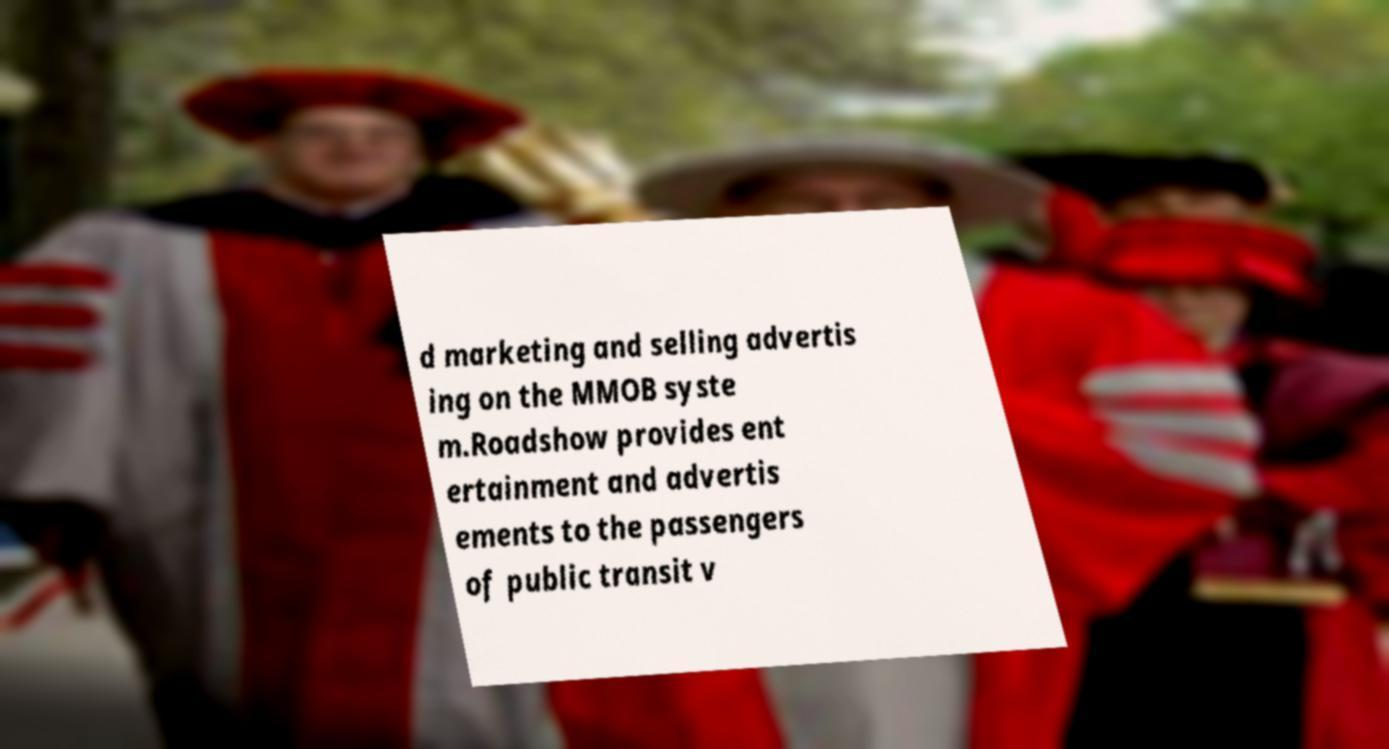Please read and relay the text visible in this image. What does it say? d marketing and selling advertis ing on the MMOB syste m.Roadshow provides ent ertainment and advertis ements to the passengers of public transit v 